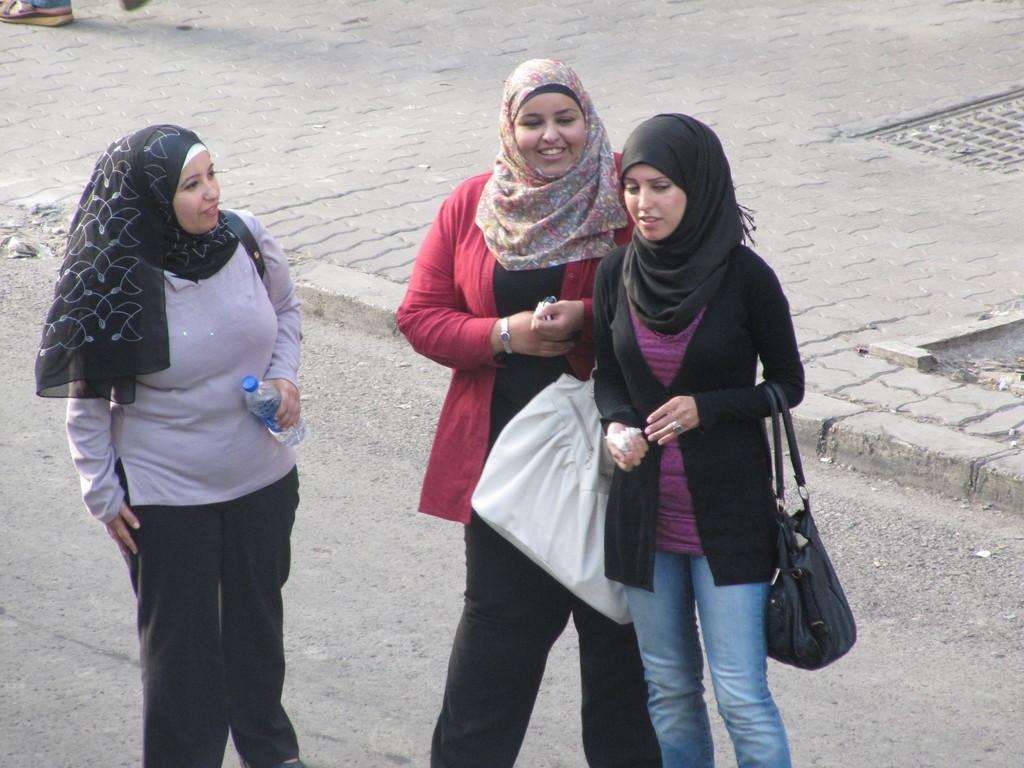How would you summarize this image in a sentence or two? In this picture I can see three persons standing, a person holding a bottle, and there is road. 